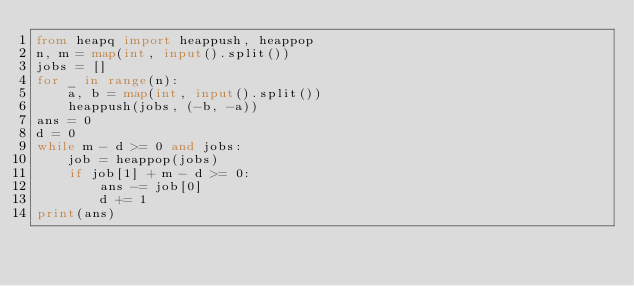Convert code to text. <code><loc_0><loc_0><loc_500><loc_500><_Python_>from heapq import heappush, heappop
n, m = map(int, input().split())
jobs = []
for _ in range(n):
    a, b = map(int, input().split())
    heappush(jobs, (-b, -a))
ans = 0
d = 0
while m - d >= 0 and jobs:
    job = heappop(jobs)
    if job[1] + m - d >= 0:
        ans -= job[0]
        d += 1
print(ans)</code> 